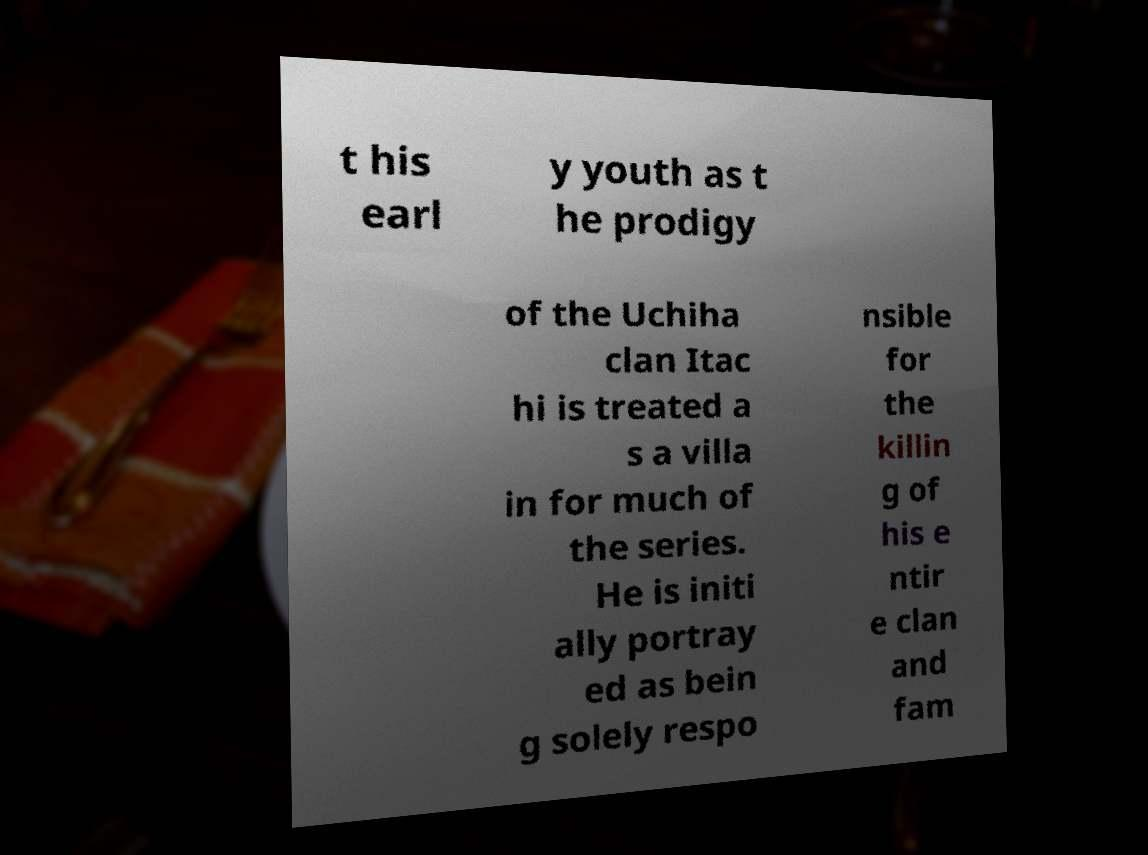What messages or text are displayed in this image? I need them in a readable, typed format. t his earl y youth as t he prodigy of the Uchiha clan Itac hi is treated a s a villa in for much of the series. He is initi ally portray ed as bein g solely respo nsible for the killin g of his e ntir e clan and fam 